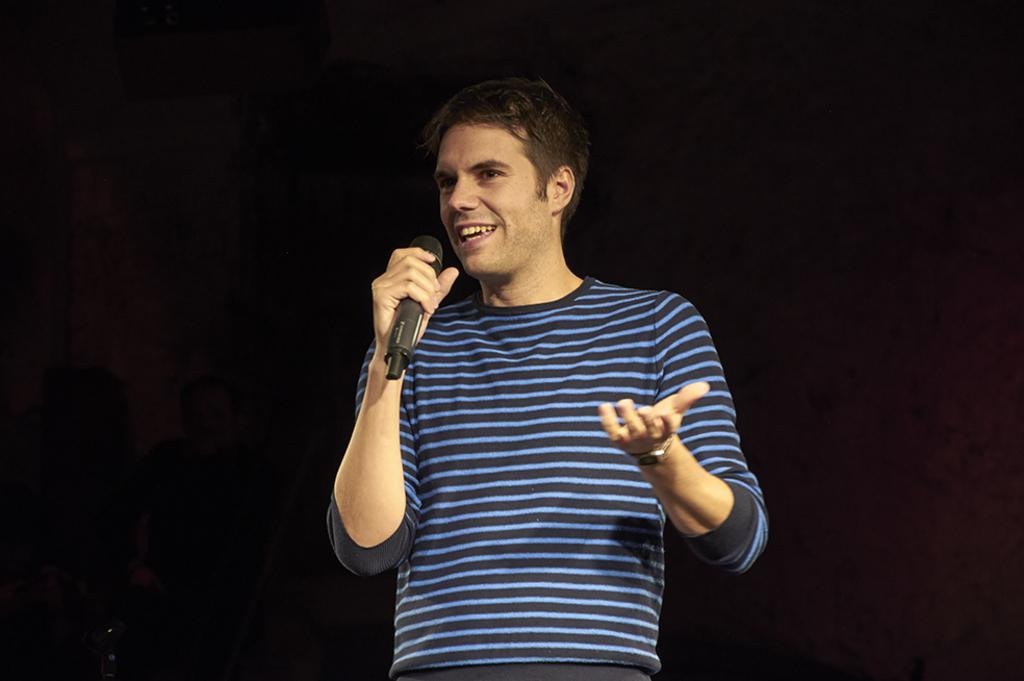What is the main subject of the image? The main subject of the image is a man. What is the man doing in the image? The man is standing and holding a mic. What is the man's facial expression in the image? The man has a smile on his face. What is the man wearing in the image? The man is wearing a blue t-shirt. What type of competition is the man participating in, as seen in the image? There is no indication of a competition in the image; the man is simply standing and holding a mic. What type of verse is the man reciting in the image? There is no indication of the man reciting a verse in the image; he is only holding a mic. 